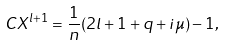<formula> <loc_0><loc_0><loc_500><loc_500>C X ^ { l + 1 } = \frac { 1 } { n } ( 2 l + 1 + q + i \mu ) - 1 ,</formula> 